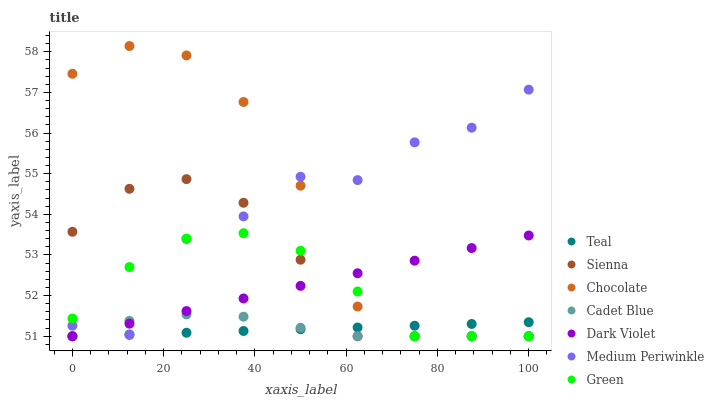Does Teal have the minimum area under the curve?
Answer yes or no. Yes. Does Chocolate have the maximum area under the curve?
Answer yes or no. Yes. Does Medium Periwinkle have the minimum area under the curve?
Answer yes or no. No. Does Medium Periwinkle have the maximum area under the curve?
Answer yes or no. No. Is Dark Violet the smoothest?
Answer yes or no. Yes. Is Medium Periwinkle the roughest?
Answer yes or no. Yes. Is Medium Periwinkle the smoothest?
Answer yes or no. No. Is Dark Violet the roughest?
Answer yes or no. No. Does Cadet Blue have the lowest value?
Answer yes or no. Yes. Does Medium Periwinkle have the lowest value?
Answer yes or no. No. Does Chocolate have the highest value?
Answer yes or no. Yes. Does Medium Periwinkle have the highest value?
Answer yes or no. No. Does Cadet Blue intersect Teal?
Answer yes or no. Yes. Is Cadet Blue less than Teal?
Answer yes or no. No. Is Cadet Blue greater than Teal?
Answer yes or no. No. 